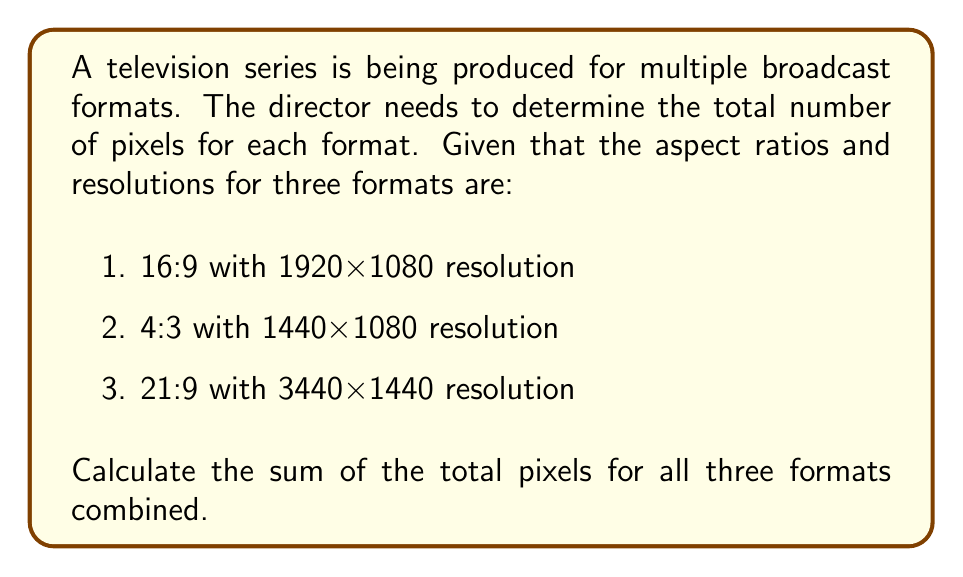Help me with this question. Let's calculate the total number of pixels for each format:

1. 16:9 format (1920x1080):
   Total pixels = $1920 \times 1080 = 2,073,600$

2. 4:3 format (1440x1080):
   Total pixels = $1440 \times 1080 = 1,555,200$

3. 21:9 format (3440x1440):
   Total pixels = $3440 \times 1440 = 4,953,600$

Now, we need to sum up the total pixels from all three formats:

$$ \text{Sum} = 2,073,600 + 1,555,200 + 4,953,600 $$

$$ \text{Sum} = 8,582,400 $$

Therefore, the sum of the total pixels for all three formats combined is 8,582,400 pixels.
Answer: 8,582,400 pixels 